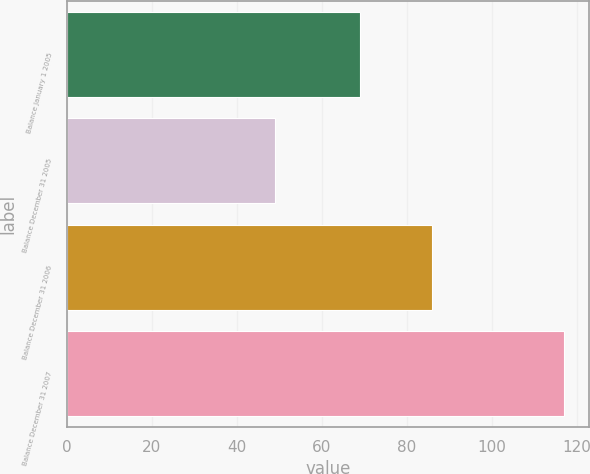Convert chart to OTSL. <chart><loc_0><loc_0><loc_500><loc_500><bar_chart><fcel>Balance January 1 2005<fcel>Balance December 31 2005<fcel>Balance December 31 2006<fcel>Balance December 31 2007<nl><fcel>69<fcel>49<fcel>86<fcel>117<nl></chart> 